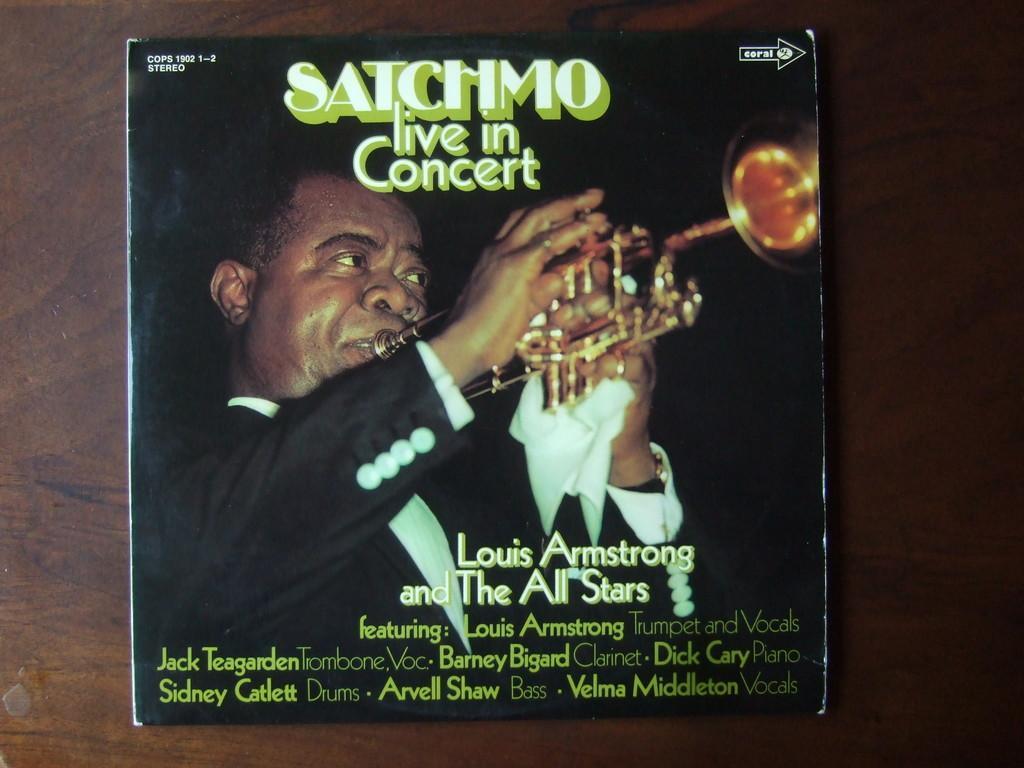Please provide a concise description of this image. In this image we can see a book placed on the table on which we can see the picture of a person playing the trumpet. We can also see some text on it. 